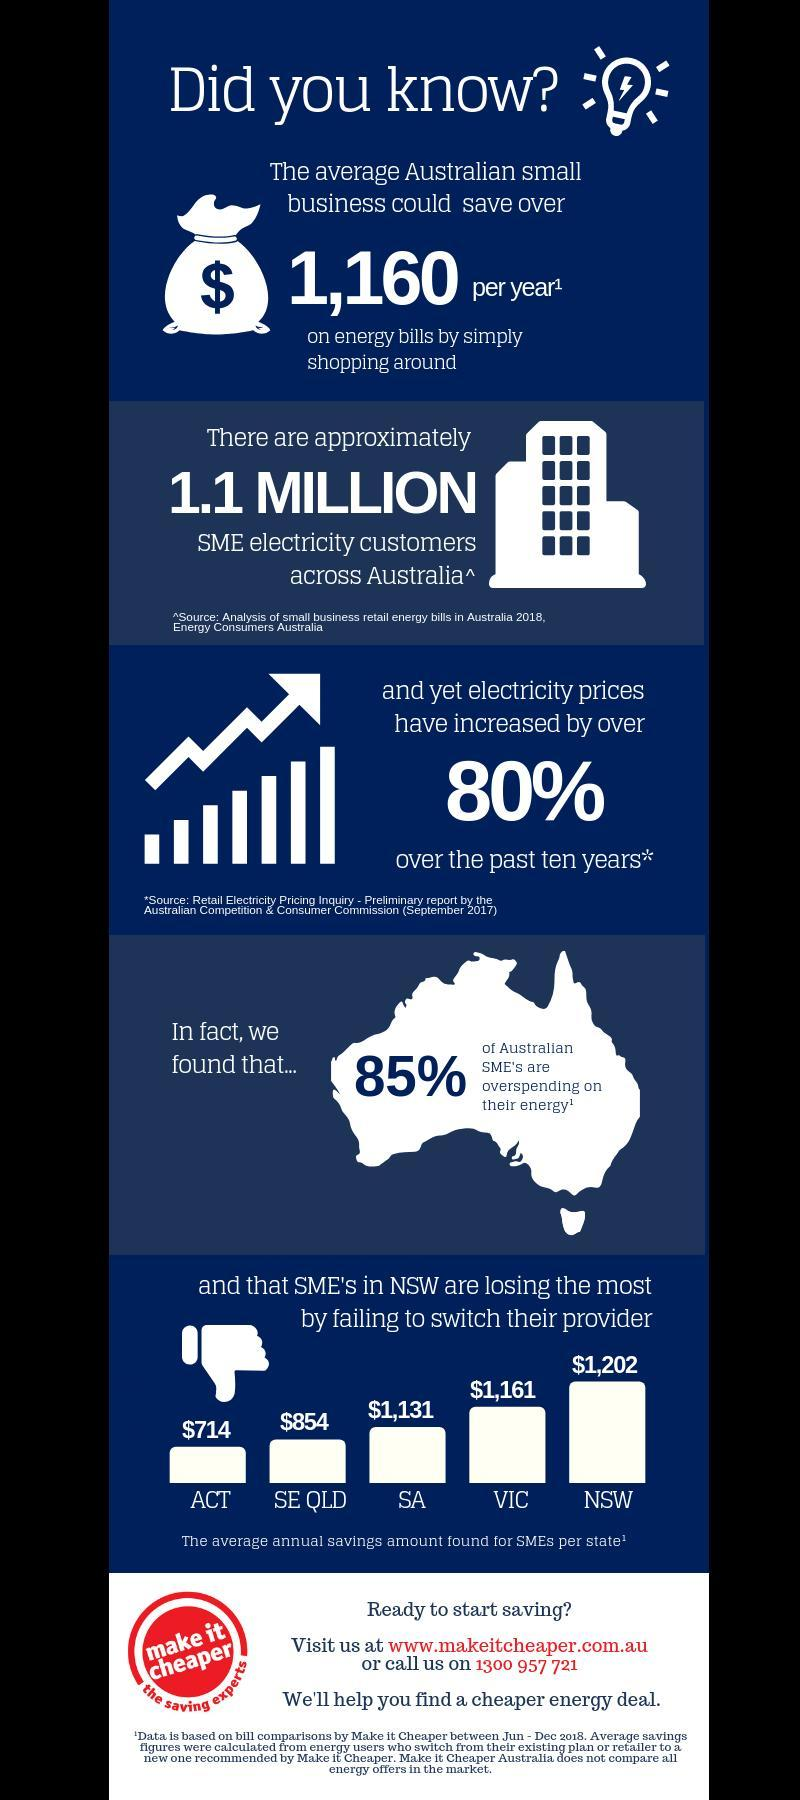Which Australian State has the third highest average annual savings amount for SMEs?
Answer the question with a short phrase. SA How many Australian state's average annual savings amount for SMEs are shown? 5 By how much Dollars is the average annual savings amount of VIC higher than ACT? $447 By how much Dollars is the average annual savings amount of NSW higher than SE QLD? $ 348 